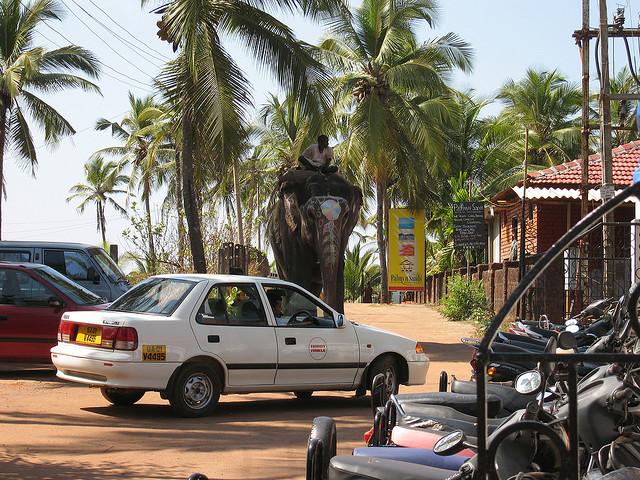What kind of trees are in this scene?
Answer briefly. Palm. What type of machine is next to the car?
Short answer required. Motorcycle. Is it daytime?
Keep it brief. Yes. What color is the closest car?
Short answer required. White. Are the palm tree trunks painted?
Quick response, please. No. 